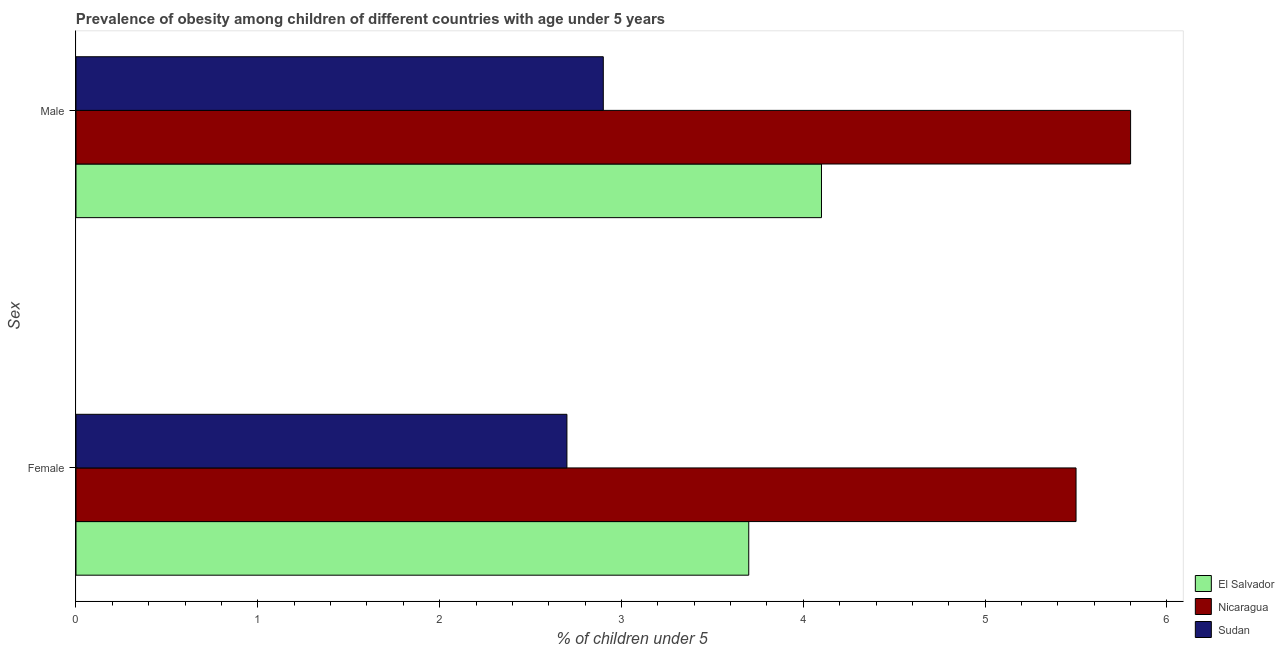How many groups of bars are there?
Your answer should be very brief. 2. Are the number of bars on each tick of the Y-axis equal?
Your response must be concise. Yes. How many bars are there on the 2nd tick from the top?
Offer a very short reply. 3. What is the percentage of obese male children in El Salvador?
Offer a very short reply. 4.1. Across all countries, what is the minimum percentage of obese female children?
Offer a terse response. 2.7. In which country was the percentage of obese male children maximum?
Ensure brevity in your answer.  Nicaragua. In which country was the percentage of obese male children minimum?
Offer a very short reply. Sudan. What is the total percentage of obese female children in the graph?
Offer a very short reply. 11.9. What is the difference between the percentage of obese male children in Nicaragua and that in Sudan?
Your answer should be very brief. 2.9. What is the difference between the percentage of obese male children in Sudan and the percentage of obese female children in El Salvador?
Provide a succinct answer. -0.8. What is the average percentage of obese female children per country?
Your response must be concise. 3.97. What is the difference between the percentage of obese female children and percentage of obese male children in El Salvador?
Offer a very short reply. -0.4. In how many countries, is the percentage of obese male children greater than 5 %?
Offer a terse response. 1. What is the ratio of the percentage of obese male children in Sudan to that in Nicaragua?
Your answer should be very brief. 0.5. Is the percentage of obese male children in El Salvador less than that in Sudan?
Keep it short and to the point. No. What does the 2nd bar from the top in Female represents?
Make the answer very short. Nicaragua. What does the 1st bar from the bottom in Male represents?
Keep it short and to the point. El Salvador. How many bars are there?
Provide a short and direct response. 6. How many countries are there in the graph?
Keep it short and to the point. 3. What is the difference between two consecutive major ticks on the X-axis?
Give a very brief answer. 1. Are the values on the major ticks of X-axis written in scientific E-notation?
Give a very brief answer. No. Does the graph contain any zero values?
Make the answer very short. No. Does the graph contain grids?
Your response must be concise. No. How many legend labels are there?
Give a very brief answer. 3. How are the legend labels stacked?
Make the answer very short. Vertical. What is the title of the graph?
Offer a very short reply. Prevalence of obesity among children of different countries with age under 5 years. Does "North America" appear as one of the legend labels in the graph?
Make the answer very short. No. What is the label or title of the X-axis?
Provide a short and direct response.  % of children under 5. What is the label or title of the Y-axis?
Keep it short and to the point. Sex. What is the  % of children under 5 of El Salvador in Female?
Keep it short and to the point. 3.7. What is the  % of children under 5 of Nicaragua in Female?
Offer a very short reply. 5.5. What is the  % of children under 5 in Sudan in Female?
Give a very brief answer. 2.7. What is the  % of children under 5 of El Salvador in Male?
Your answer should be compact. 4.1. What is the  % of children under 5 in Nicaragua in Male?
Your answer should be very brief. 5.8. What is the  % of children under 5 of Sudan in Male?
Make the answer very short. 2.9. Across all Sex, what is the maximum  % of children under 5 of El Salvador?
Keep it short and to the point. 4.1. Across all Sex, what is the maximum  % of children under 5 of Nicaragua?
Your answer should be compact. 5.8. Across all Sex, what is the maximum  % of children under 5 in Sudan?
Ensure brevity in your answer.  2.9. Across all Sex, what is the minimum  % of children under 5 of El Salvador?
Keep it short and to the point. 3.7. Across all Sex, what is the minimum  % of children under 5 in Nicaragua?
Ensure brevity in your answer.  5.5. Across all Sex, what is the minimum  % of children under 5 of Sudan?
Keep it short and to the point. 2.7. What is the total  % of children under 5 in El Salvador in the graph?
Give a very brief answer. 7.8. What is the total  % of children under 5 in Nicaragua in the graph?
Make the answer very short. 11.3. What is the total  % of children under 5 of Sudan in the graph?
Make the answer very short. 5.6. What is the difference between the  % of children under 5 of Nicaragua in Female and that in Male?
Your response must be concise. -0.3. What is the difference between the  % of children under 5 in Sudan in Female and that in Male?
Provide a succinct answer. -0.2. What is the average  % of children under 5 in Nicaragua per Sex?
Provide a short and direct response. 5.65. What is the difference between the  % of children under 5 in Nicaragua and  % of children under 5 in Sudan in Female?
Give a very brief answer. 2.8. What is the difference between the  % of children under 5 in El Salvador and  % of children under 5 in Sudan in Male?
Your answer should be very brief. 1.2. What is the difference between the  % of children under 5 in Nicaragua and  % of children under 5 in Sudan in Male?
Ensure brevity in your answer.  2.9. What is the ratio of the  % of children under 5 in El Salvador in Female to that in Male?
Offer a terse response. 0.9. What is the ratio of the  % of children under 5 of Nicaragua in Female to that in Male?
Keep it short and to the point. 0.95. What is the difference between the highest and the lowest  % of children under 5 in Nicaragua?
Provide a short and direct response. 0.3. 